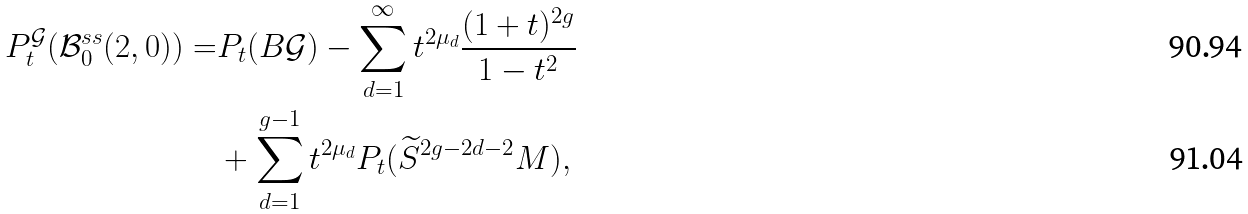<formula> <loc_0><loc_0><loc_500><loc_500>P _ { t } ^ { \mathcal { G } } ( \mathcal { B } _ { 0 } ^ { s s } ( 2 , 0 ) ) = & P _ { t } ( B \mathcal { G } ) - \sum _ { d = 1 } ^ { \infty } t ^ { 2 \mu _ { d } } \frac { ( 1 + t ) ^ { 2 g } } { 1 - t ^ { 2 } } \\ & + \sum _ { d = 1 } ^ { g - 1 } t ^ { 2 \mu _ { d } } P _ { t } ( \widetilde { S } ^ { 2 g - 2 d - 2 } M ) ,</formula> 